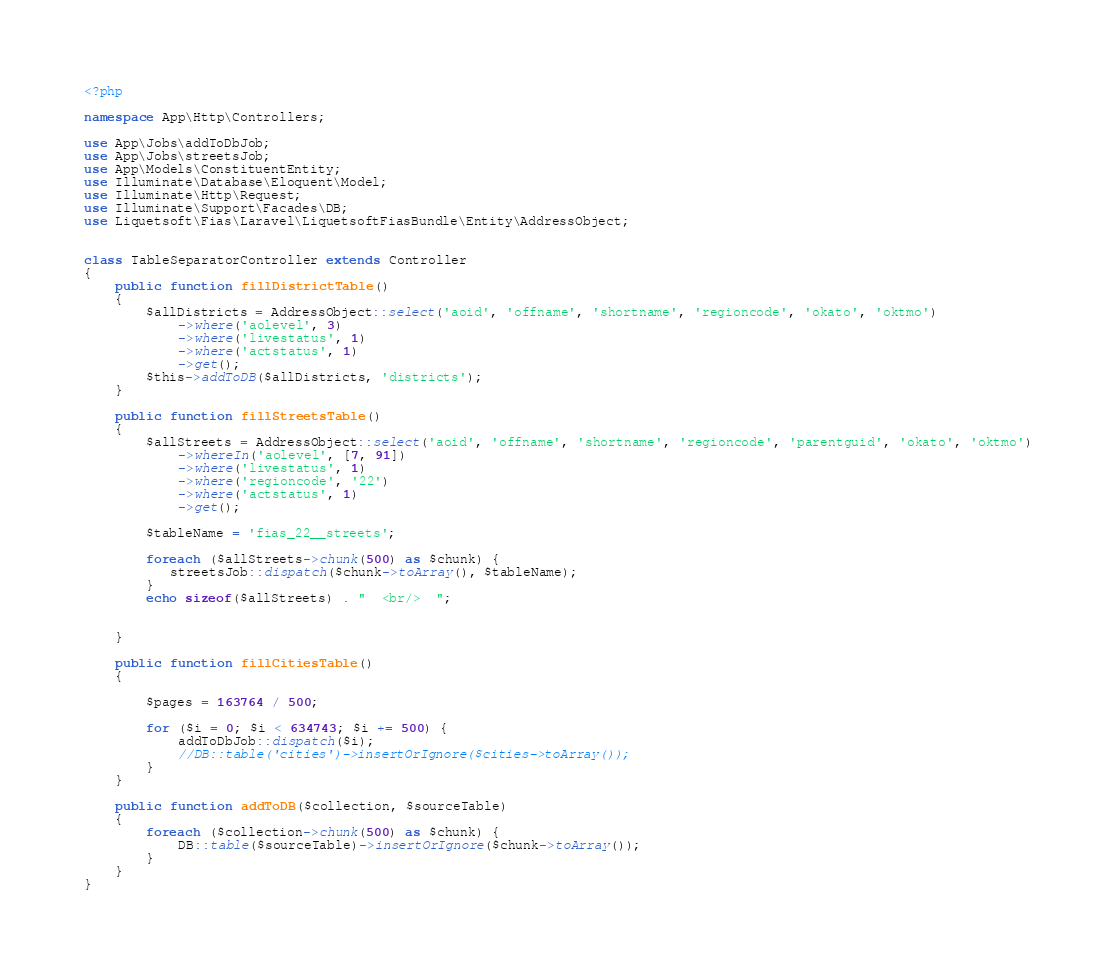<code> <loc_0><loc_0><loc_500><loc_500><_PHP_><?php

namespace App\Http\Controllers;

use App\Jobs\addToDbJob;
use App\Jobs\streetsJob;
use App\Models\ConstituentEntity;
use Illuminate\Database\Eloquent\Model;
use Illuminate\Http\Request;
use Illuminate\Support\Facades\DB;
use Liquetsoft\Fias\Laravel\LiquetsoftFiasBundle\Entity\AddressObject;


class TableSeparatorController extends Controller
{
    public function fillDistrictTable()
    {
        $allDistricts = AddressObject::select('aoid', 'offname', 'shortname', 'regioncode', 'okato', 'oktmo')
            ->where('aolevel', 3)
            ->where('livestatus', 1)
            ->where('actstatus', 1)
            ->get();
        $this->addToDB($allDistricts, 'districts');
    }

    public function fillStreetsTable()
    {
        $allStreets = AddressObject::select('aoid', 'offname', 'shortname', 'regioncode', 'parentguid', 'okato', 'oktmo')
            ->whereIn('aolevel', [7, 91])
            ->where('livestatus', 1)
            ->where('regioncode', '22')
            ->where('actstatus', 1)
            ->get();

        $tableName = 'fias_22__streets';

        foreach ($allStreets->chunk(500) as $chunk) {
           streetsJob::dispatch($chunk->toArray(), $tableName);
        }
        echo sizeof($allStreets) . "  <br/>  ";


    }

    public function fillCitiesTable()
    {

        $pages = 163764 / 500;

        for ($i = 0; $i < 634743; $i += 500) {
            addToDbJob::dispatch($i);
            //DB::table('cities')->insertOrIgnore($cities->toArray());
        }
    }

    public function addToDB($collection, $sourceTable)
    {
        foreach ($collection->chunk(500) as $chunk) {
            DB::table($sourceTable)->insertOrIgnore($chunk->toArray());
        }
    }
}
</code> 